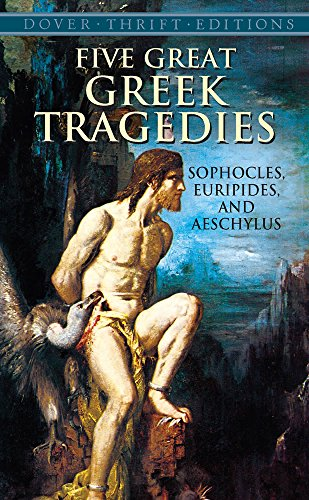Can you tell me more about the theme of the artwork on this book's cover? The cover artwork features a classical depiction of Prometheus, a figure from Greek mythology known for his intelligence and for defying the gods by giving fire to humanity, representative of the tragic spirit and profound themes of the plays within. Which tragedy does this figure relate to? Prometheus is the central figure in 'Prometheus Bound', a tragedy often attributed to Aeschylus, where his defiance against Zeus and consequent punishment captures the essence of tragic conflict. 